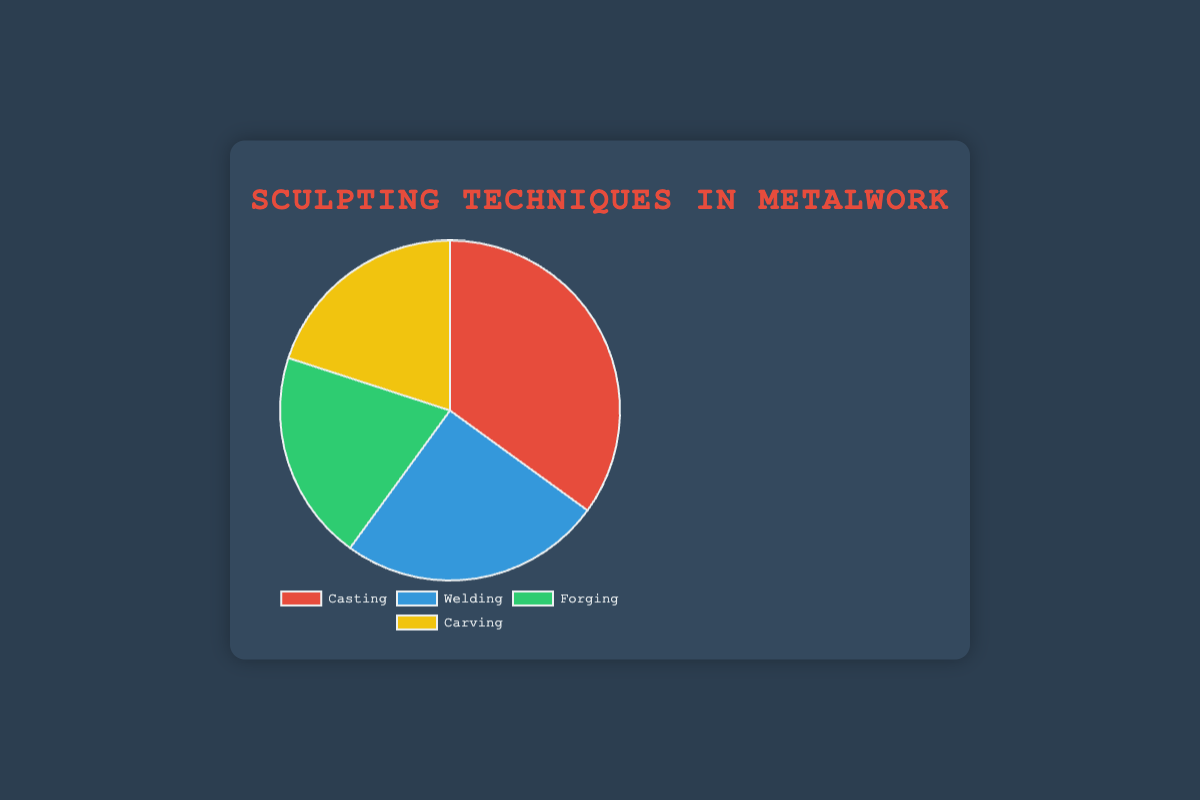What's the most common sculpting technique used by metalwork artists? The pie chart shows the percentages of different sculpting techniques. Casting has the largest slice at 35%, indicating it is the most common technique.
Answer: Casting Which technique has the smallest percentage, and what is that percentage? By observing the pie chart, we see that both Forging and Carving have equal slices, each contributing 20%, which is the smallest percentage among the techniques listed.
Answer: Forging and Carving, each 20% What is the combined percentage of artists using Welding and Forging techniques? The percentages for Welding and Forging are 25% and 20% respectively. Adding these together, we get 25% + 20% = 45%.
Answer: 45% Is the proportion of artists using casting greater than those using welding and forging combined? Casting has 35%, Welding has 25%, and Forging has 20%. Together, Welding and Forging add up to 45%. Since 35% < 45%, Casting is not greater than Welding and Forging combined.
Answer: No What's the difference in percentage between the most and least common techniques? The most common technique is Casting at 35%, and the least common techniques are Forging and Carving at 20% each. The difference is 35% - 20% = 15%.
Answer: 15% Which color represents the Welding technique in the chart? The pie chart uses specific colors for each technique. Welding's slice is colored blue.
Answer: Blue If another technique were to be added that accounted for 10% of the total, what would the new percentage for the remaining techniques be? Currently, the cumulative percentage is 35% (Casting) + 25% (Welding) + 20% (Forging) + 20% (Carving) = 100%. If a new technique is added with 10%, the total becomes 110%. To find the new percentages of the remaining techniques, we must scale their original values: Casting becomes 35/110 * 100 = 31.82%, Welding becomes 22.73%, Forging and Carving each become 18.18%.
Answer: Casting: 31.82%, Welding: 22.73%, Forging: 18.18%, Carving: 18.18% What percentage of artists use either Casting or Carving techniques? The percentages are 35% for Casting and 20% for Carving. Adding them together, 35% + 20% = 55%.
Answer: 55% Is the percentage of artists using Welding roughly equal to those using Carving? Both Welding and Carving have relatively similar percentages, Welding with 25% and Carving with 20%, though Welding is slightly higher by 5%.
Answer: No 